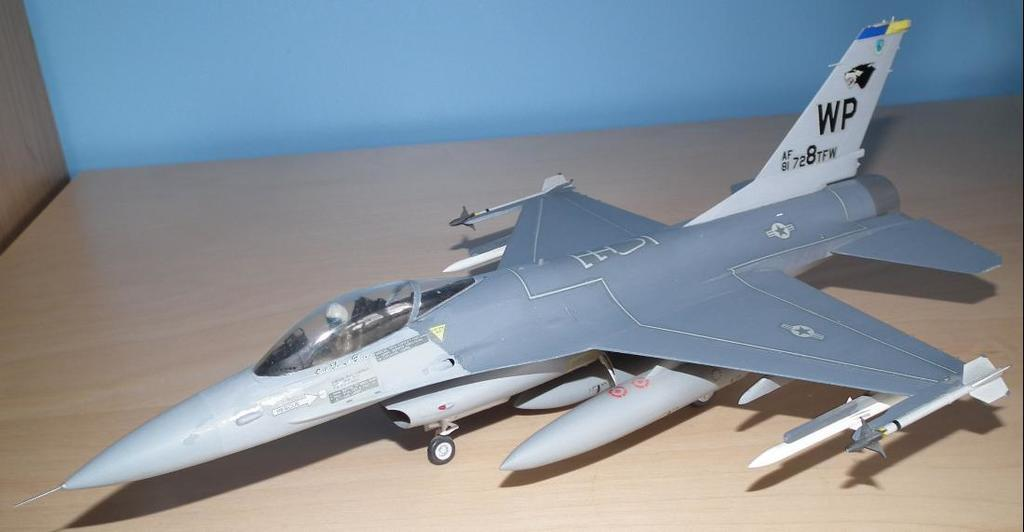Provide a one-sentence caption for the provided image. A model of a silver jet is on a table with the letters WP on its tail. 